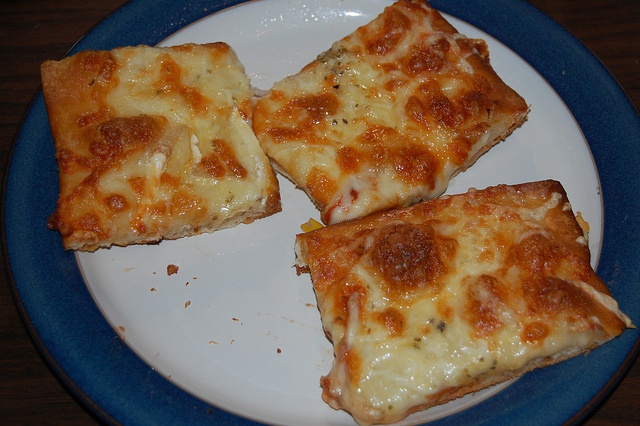Describe the objects in this image and their specific colors. I can see dining table in darkgray, brown, black, tan, and navy tones and pizza in black, brown, tan, maroon, and gray tones in this image. 